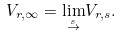<formula> <loc_0><loc_0><loc_500><loc_500>V _ { r , \infty } = \underset { \overset { s } { \rightarrow } } { \lim } V _ { r , s } .</formula> 